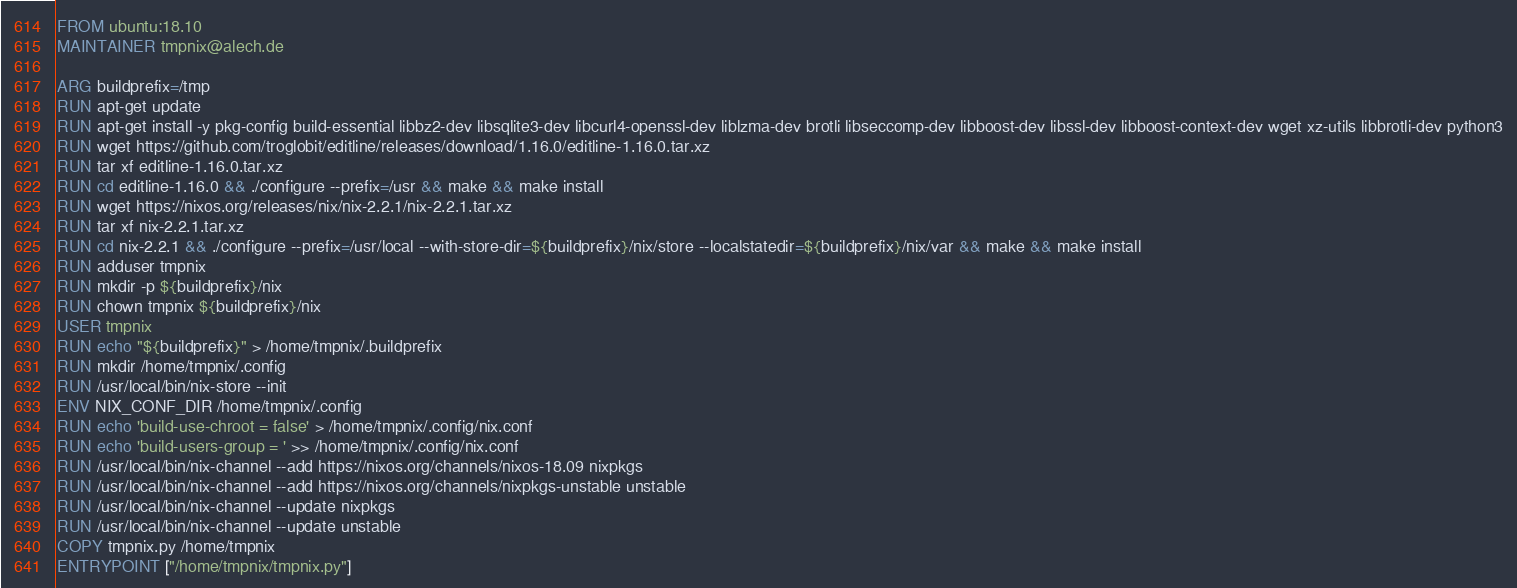<code> <loc_0><loc_0><loc_500><loc_500><_Dockerfile_>FROM ubuntu:18.10
MAINTAINER tmpnix@alech.de

ARG buildprefix=/tmp
RUN apt-get update
RUN apt-get install -y pkg-config build-essential libbz2-dev libsqlite3-dev libcurl4-openssl-dev liblzma-dev brotli libseccomp-dev libboost-dev libssl-dev libboost-context-dev wget xz-utils libbrotli-dev python3
RUN wget https://github.com/troglobit/editline/releases/download/1.16.0/editline-1.16.0.tar.xz
RUN tar xf editline-1.16.0.tar.xz
RUN cd editline-1.16.0 && ./configure --prefix=/usr && make && make install
RUN wget https://nixos.org/releases/nix/nix-2.2.1/nix-2.2.1.tar.xz
RUN tar xf nix-2.2.1.tar.xz
RUN cd nix-2.2.1 && ./configure --prefix=/usr/local --with-store-dir=${buildprefix}/nix/store --localstatedir=${buildprefix}/nix/var && make && make install
RUN adduser tmpnix
RUN mkdir -p ${buildprefix}/nix
RUN chown tmpnix ${buildprefix}/nix
USER tmpnix
RUN echo "${buildprefix}" > /home/tmpnix/.buildprefix
RUN mkdir /home/tmpnix/.config
RUN /usr/local/bin/nix-store --init
ENV NIX_CONF_DIR /home/tmpnix/.config
RUN echo 'build-use-chroot = false' > /home/tmpnix/.config/nix.conf
RUN echo 'build-users-group = ' >> /home/tmpnix/.config/nix.conf
RUN /usr/local/bin/nix-channel --add https://nixos.org/channels/nixos-18.09 nixpkgs
RUN /usr/local/bin/nix-channel --add https://nixos.org/channels/nixpkgs-unstable unstable
RUN /usr/local/bin/nix-channel --update nixpkgs
RUN /usr/local/bin/nix-channel --update unstable
COPY tmpnix.py /home/tmpnix
ENTRYPOINT ["/home/tmpnix/tmpnix.py"]
</code> 